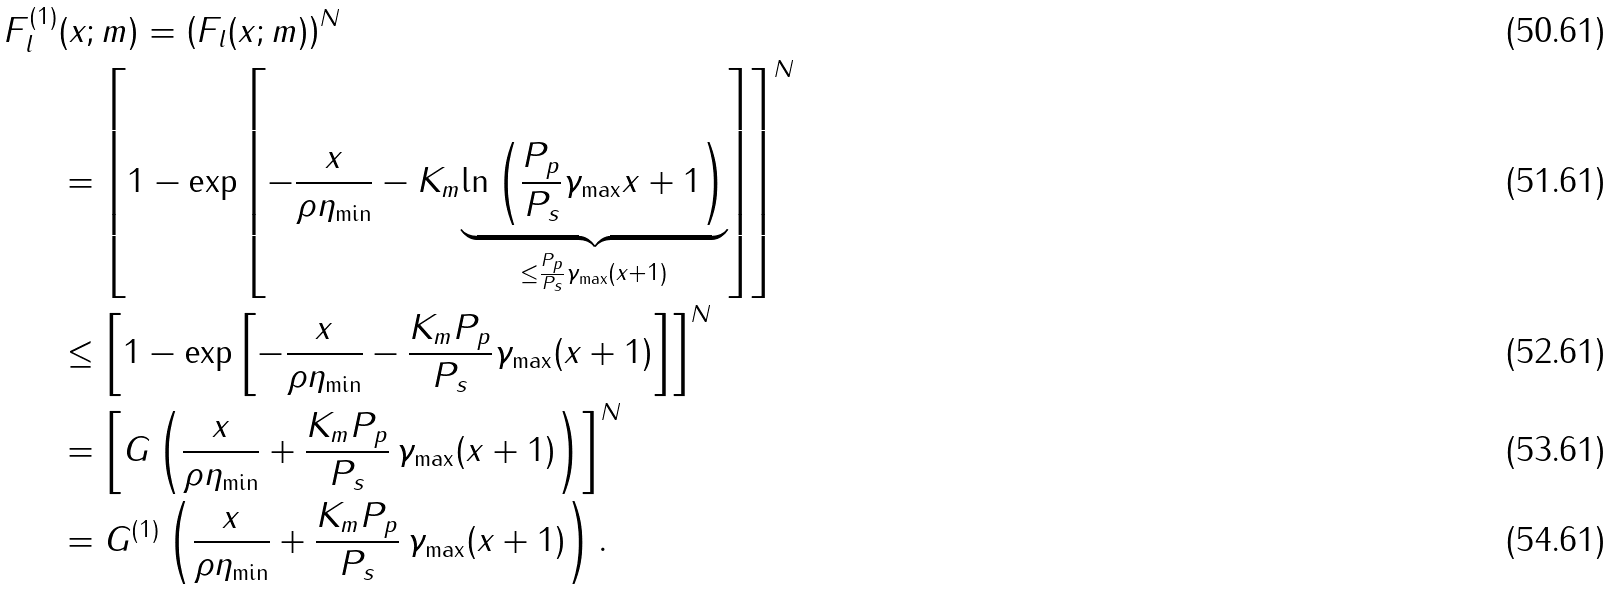Convert formula to latex. <formula><loc_0><loc_0><loc_500><loc_500>F _ { l } ^ { ( 1 ) } & ( x ; m ) = \left ( F _ { l } ( x ; m ) \right ) ^ { N } \\ & = \left [ 1 - \exp \left [ - \frac { x } { \rho \eta _ { \min } } - K _ { m } \underset { \leq \frac { P _ { p } } { P _ { s } } \gamma _ { \max } ( x + 1 ) } { \underbrace { \ln \left ( \frac { P _ { p } } { P _ { s } } \gamma _ { \max } x + 1 \right ) } } \right ] \right ] ^ { N } \\ & \leq \left [ 1 - \exp \left [ - \frac { x } { \rho \eta _ { \min } } - \frac { K _ { m } P _ { p } } { P _ { s } } \gamma _ { \max } ( x + 1 ) \right ] \right ] ^ { N } \\ & = \left [ G \left ( \frac { x } { \rho \eta _ { \min } } + \frac { K _ { m } P _ { p } } { P _ { s } } \, \gamma _ { \max } ( x + 1 ) \right ) \right ] ^ { N } \\ & = G ^ { ( 1 ) } \left ( \frac { x } { \rho \eta _ { \min } } + \frac { K _ { m } P _ { p } } { P _ { s } } \, \gamma _ { \max } ( x + 1 ) \right ) .</formula> 